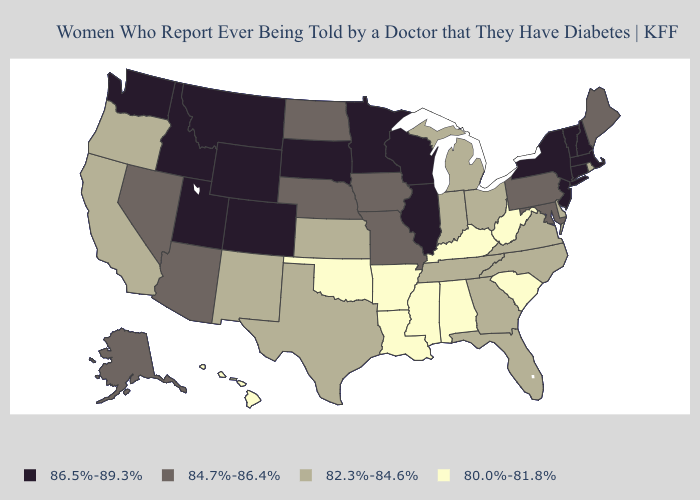Does Iowa have the same value as Nebraska?
Short answer required. Yes. Does Montana have a higher value than Massachusetts?
Short answer required. No. What is the value of Alabama?
Quick response, please. 80.0%-81.8%. What is the value of Colorado?
Keep it brief. 86.5%-89.3%. Name the states that have a value in the range 82.3%-84.6%?
Write a very short answer. California, Delaware, Florida, Georgia, Indiana, Kansas, Michigan, New Mexico, North Carolina, Ohio, Oregon, Rhode Island, Tennessee, Texas, Virginia. Does Hawaii have the lowest value in the USA?
Keep it brief. Yes. Name the states that have a value in the range 82.3%-84.6%?
Give a very brief answer. California, Delaware, Florida, Georgia, Indiana, Kansas, Michigan, New Mexico, North Carolina, Ohio, Oregon, Rhode Island, Tennessee, Texas, Virginia. Does Minnesota have the highest value in the MidWest?
Quick response, please. Yes. How many symbols are there in the legend?
Quick response, please. 4. Among the states that border Michigan , does Wisconsin have the highest value?
Write a very short answer. Yes. Among the states that border Georgia , which have the lowest value?
Be succinct. Alabama, South Carolina. What is the value of Indiana?
Short answer required. 82.3%-84.6%. Does Utah have the same value as Kansas?
Short answer required. No. How many symbols are there in the legend?
Keep it brief. 4. Name the states that have a value in the range 80.0%-81.8%?
Answer briefly. Alabama, Arkansas, Hawaii, Kentucky, Louisiana, Mississippi, Oklahoma, South Carolina, West Virginia. 